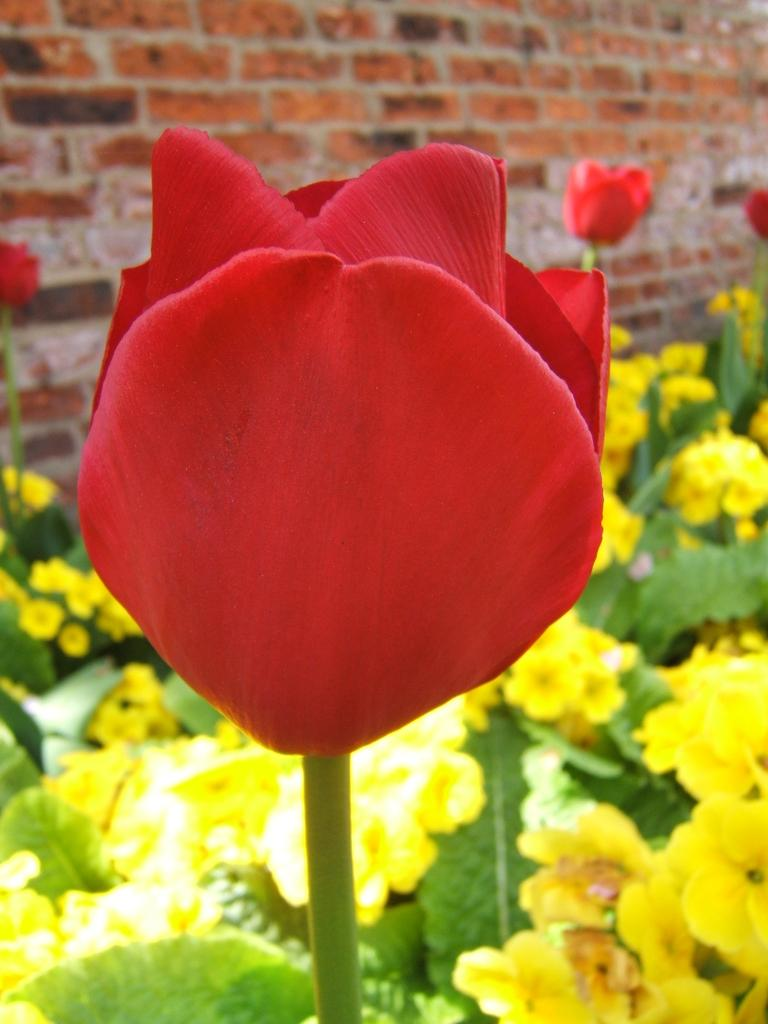What type of flower is in the image? There is a tulip flower in the image. What is the color of the tulip flower? The tulip flower has a red color. What part of the tulip flower is visible in the image? The tulip flower has a stem in the image. What other type of flower can be seen in the image? There are plants with yellow flowers in the image. What is the texture of the background in the image? The background has a brick texture. What type of scarf is draped over the tulip flower in the image? There is no scarf present in the image; it is a tulip flower with a stem and surrounded by plants with yellow flowers. Can you tell me how many yams are visible in the image? There are no yams present in the image; it is a garden scene with flowers and a brick background. 